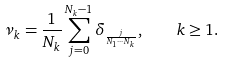Convert formula to latex. <formula><loc_0><loc_0><loc_500><loc_500>\nu _ { k } = \frac { 1 } { N _ { k } } \sum _ { j = 0 } ^ { N _ { k } - 1 } \delta _ { \frac { j } { N _ { 1 } \cdots N _ { k } } } , \quad k \geq 1 .</formula> 